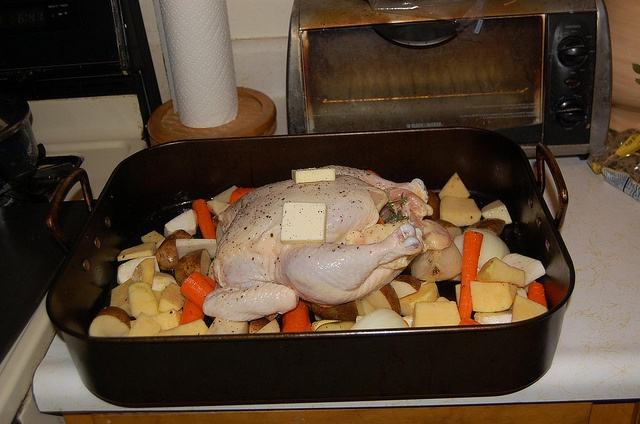Describe the objects in this image and their specific colors. I can see microwave in black, maroon, and gray tones, oven in black and gray tones, carrot in black, brown, and red tones, carrot in black, red, and brown tones, and carrot in black, brown, maroon, and red tones in this image. 